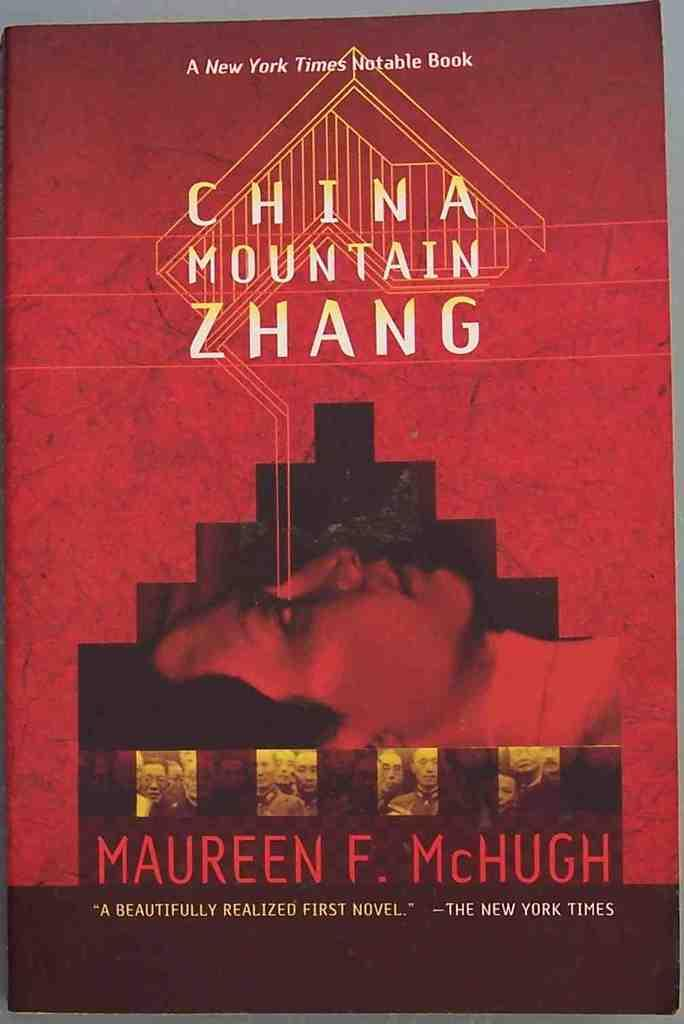<image>
Share a concise interpretation of the image provided. A novel entitled "China Mountain Zhang" by Maureen F. McHugh. 